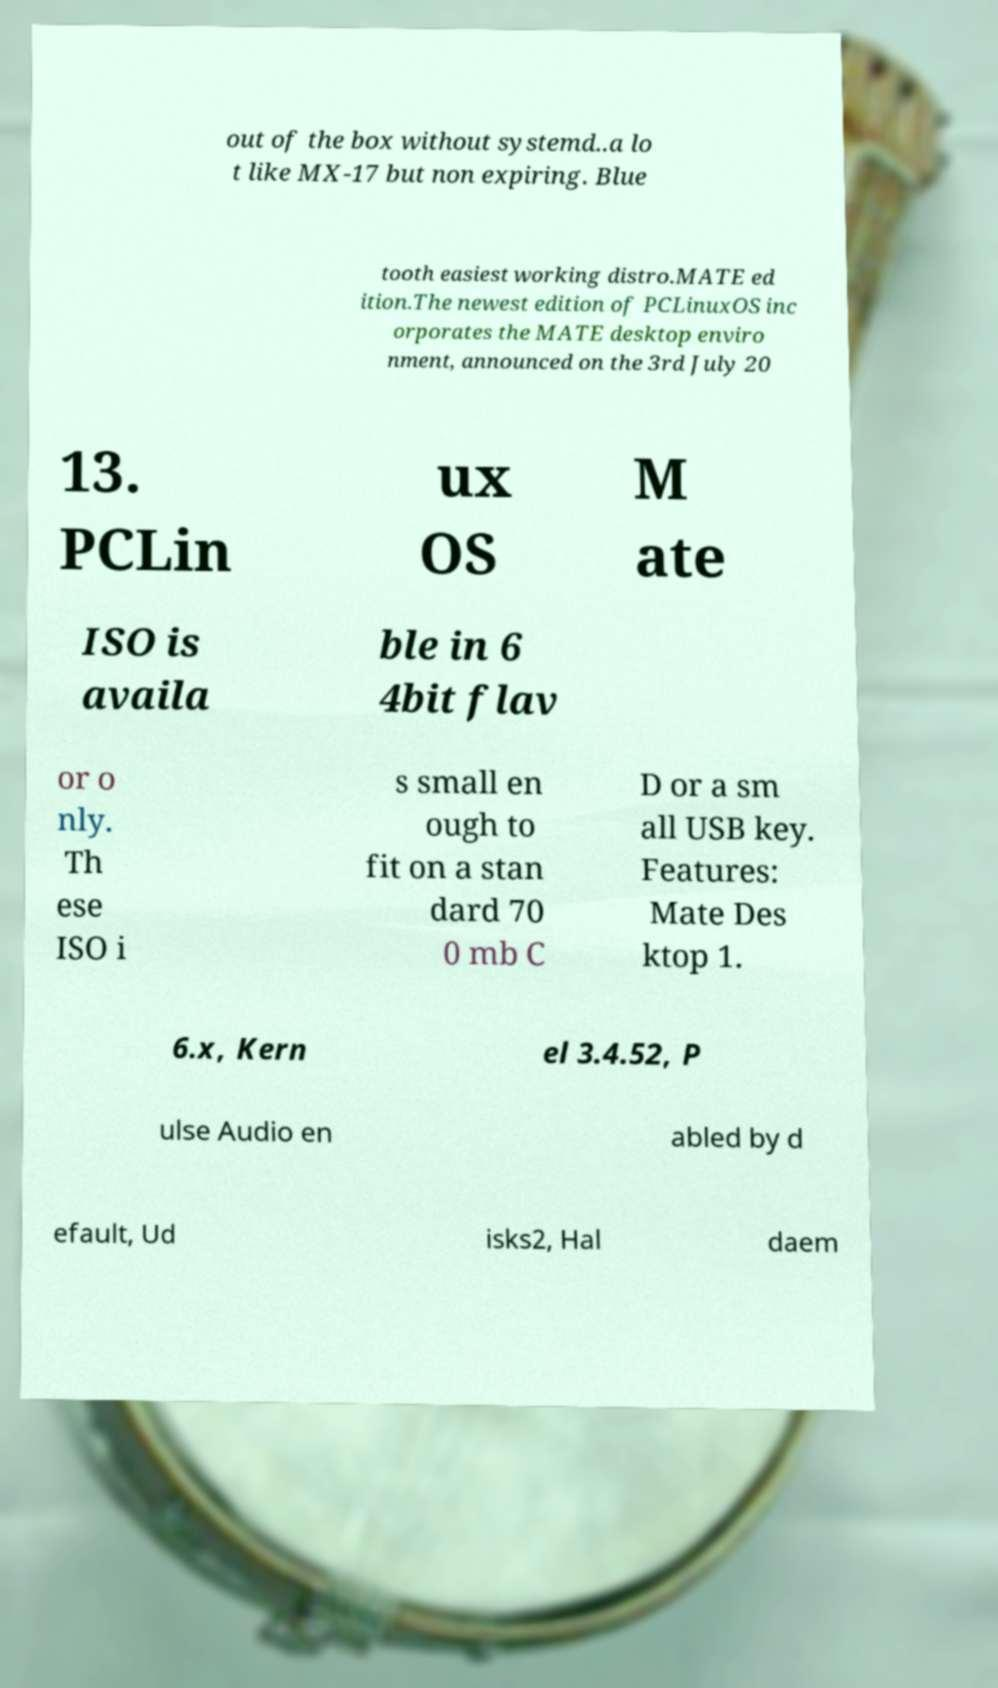Could you assist in decoding the text presented in this image and type it out clearly? out of the box without systemd..a lo t like MX-17 but non expiring. Blue tooth easiest working distro.MATE ed ition.The newest edition of PCLinuxOS inc orporates the MATE desktop enviro nment, announced on the 3rd July 20 13. PCLin ux OS M ate ISO is availa ble in 6 4bit flav or o nly. Th ese ISO i s small en ough to fit on a stan dard 70 0 mb C D or a sm all USB key. Features: Mate Des ktop 1. 6.x, Kern el 3.4.52, P ulse Audio en abled by d efault, Ud isks2, Hal daem 